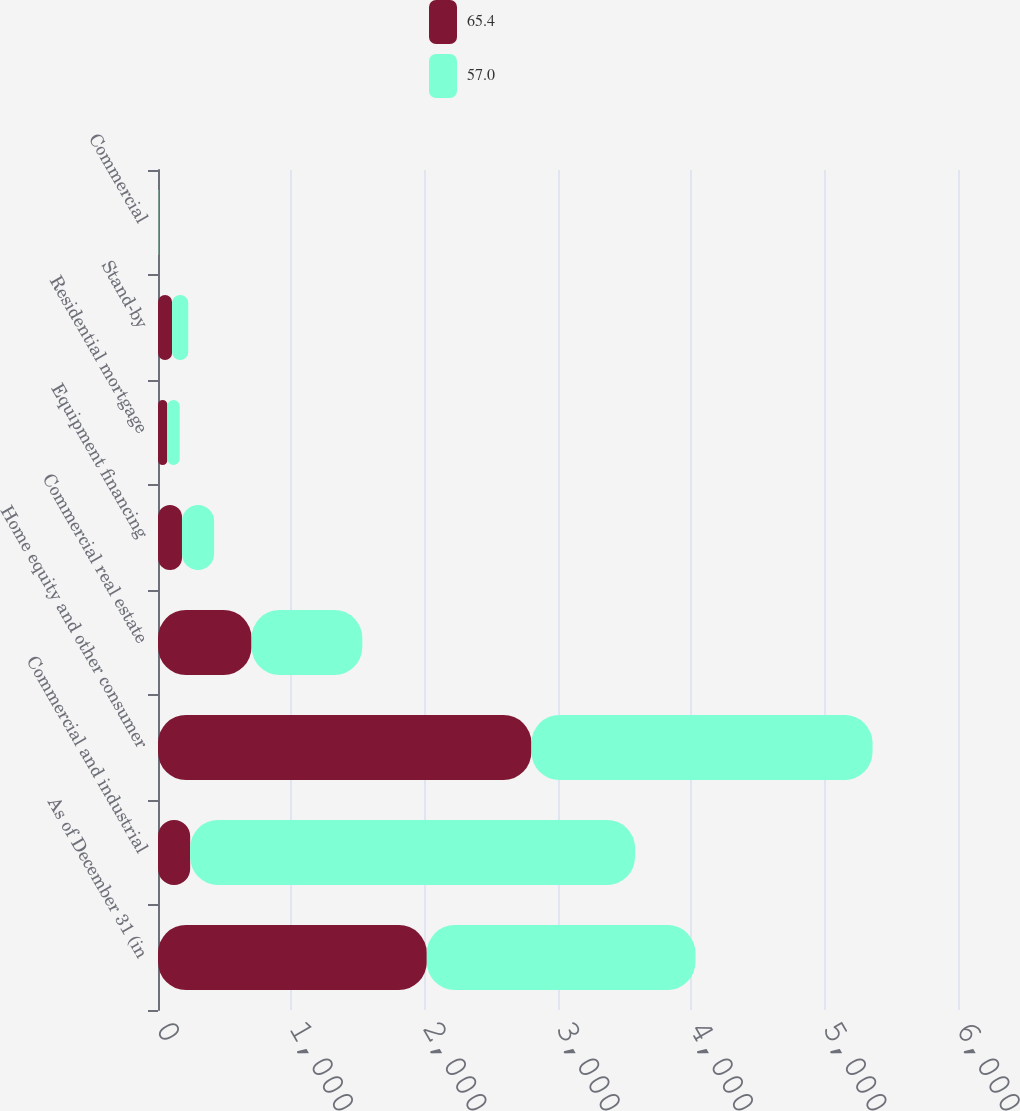<chart> <loc_0><loc_0><loc_500><loc_500><stacked_bar_chart><ecel><fcel>As of December 31 (in<fcel>Commercial and industrial<fcel>Home equity and other consumer<fcel>Commercial real estate<fcel>Equipment financing<fcel>Residential mortgage<fcel>Stand-by<fcel>Commercial<nl><fcel>65.4<fcel>2016<fcel>241<fcel>2800.7<fcel>701.6<fcel>179.9<fcel>69.6<fcel>105.6<fcel>3.6<nl><fcel>57<fcel>2015<fcel>3337<fcel>2558.4<fcel>831<fcel>241<fcel>93.3<fcel>121.5<fcel>3.4<nl></chart> 